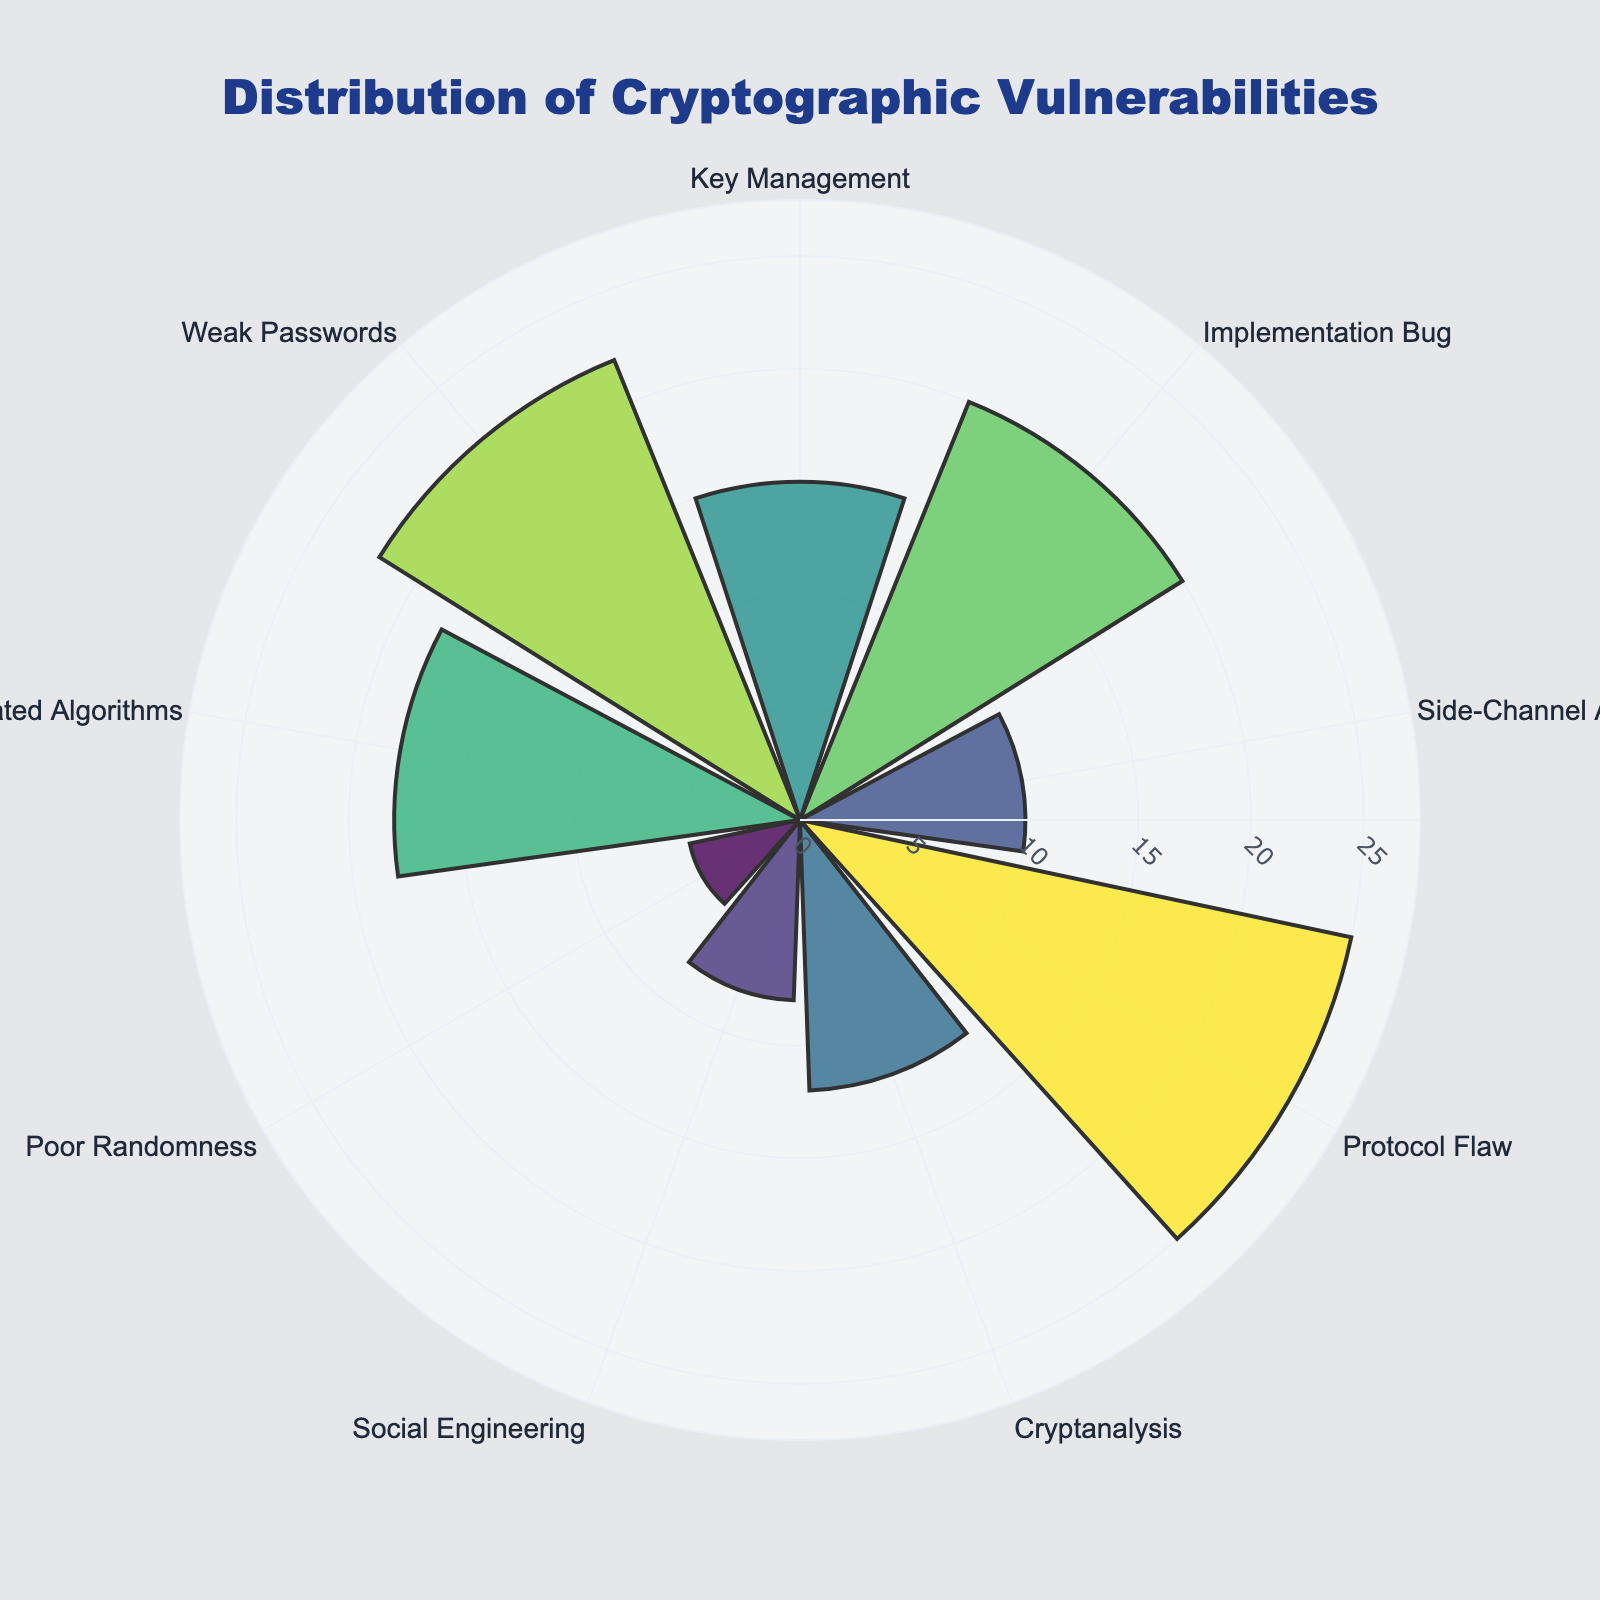What is the title of the figure? The title is usually located at the top of the figure and provides a summary of what the figure is about. In this case, the title reads "Distribution of Cryptographic Vulnerabilities".
Answer: Distribution of Cryptographic Vulnerabilities How many categories of cryptographic vulnerabilities are presented? Count the number of distinct labels on the theta (angular) axis of the rose chart to determine the number of categories. There are nine such labels corresponding to the cryptographic vulnerability categories.
Answer: 9 Which category has the most vulnerabilities? Look for the barpolar segment with the largest value on the radial axis. The category with the highest radial length is "Protocol Flaw".
Answer: Protocol Flaw What is the vulnerability count for the "Side-Channel Attack" category? Identify the segment labeled "Side-Channel Attack" and read its corresponding value on the radial axis. The value is 10.
Answer: 10 What is the difference in vulnerability count between "Weak Passwords" and "Poor Randomness"? Locate the categories "Weak Passwords" and "Poor Randomness" on the angular scale, then note their radial values (22 and 5, respectively). The difference is calculated as 22 - 5.
Answer: 17 How many more vulnerabilities does "Outdated Algorithms" have compared to "Social Engineering"? Identify the radial values for "Outdated Algorithms" (18) and "Social Engineering" (8). Compute the difference: 18 - 8.
Answer: 10 Which category has the lowest number of vulnerabilities? Locate the category with the shortest radial length on the rose chart. "Poor Randomness" is the category with the lowest count.
Answer: Poor Randomness What is the average vulnerability count across all categories? Sum the vulnerability counts for all categories (15 + 20 + 10 + 25 + 12 + 8 + 5 + 18 + 22 = 135). Divide by the number of categories (9).
Answer: 15 Compare the vulnerability counts of "Implementation Bug" and "Cryptanalysis". Which one is higher and by how much? Find the radial values for "Implementation Bug" (20) and "Cryptanalysis" (12). Subtract the value of "Cryptanalysis" from "Implementation Bug": 20 - 12. "Implementation Bug" is higher.
Answer: Implementation Bug by 8 What is the combined vulnerability count for "Key Management" and "Weak Passwords"? Add the radial values for "Key Management" (15) and "Weak Passwords" (22): 15 + 22.
Answer: 37 